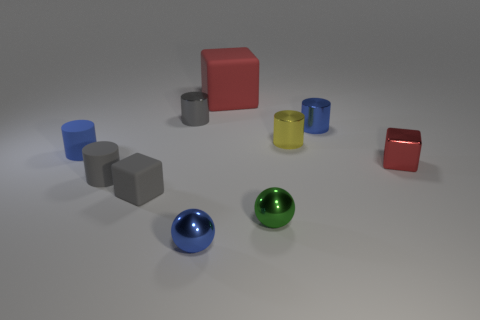Is there any other thing that has the same color as the big object?
Provide a short and direct response. Yes. Is the color of the small metal cube the same as the matte cube behind the blue metal cylinder?
Ensure brevity in your answer.  Yes. Is the number of red blocks that are behind the big matte block less than the number of red balls?
Your answer should be compact. No. What color is the large thing?
Provide a short and direct response. Red. Do the tiny shiny thing to the left of the tiny blue metal sphere and the small matte cube have the same color?
Your response must be concise. Yes. There is another thing that is the same shape as the green object; what is its color?
Your response must be concise. Blue. What number of big things are matte cylinders or shiny cylinders?
Your answer should be very brief. 0. There is a cube that is behind the gray shiny object; what size is it?
Provide a short and direct response. Large. Is there a cylinder that has the same color as the big thing?
Provide a short and direct response. No. Is the color of the tiny metallic cube the same as the large matte cube?
Provide a short and direct response. Yes. 